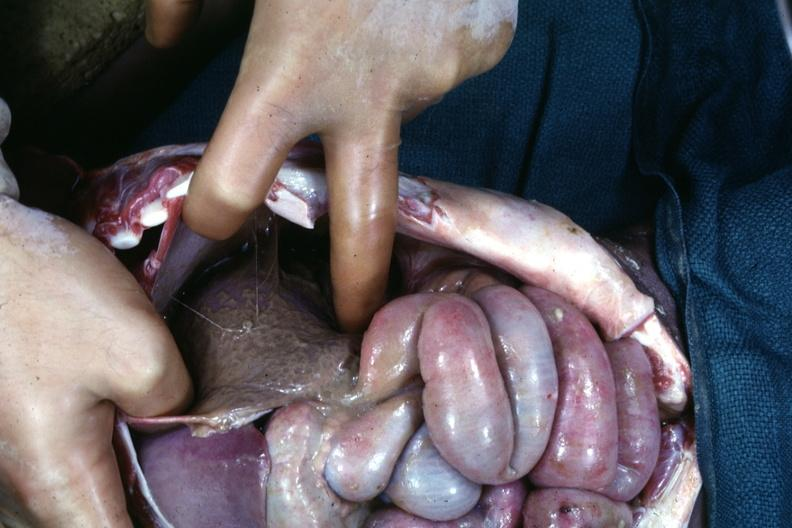s subdiaphragmatic abscess present?
Answer the question using a single word or phrase. Yes 